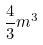Convert formula to latex. <formula><loc_0><loc_0><loc_500><loc_500>\frac { 4 } { 3 } m ^ { 3 }</formula> 